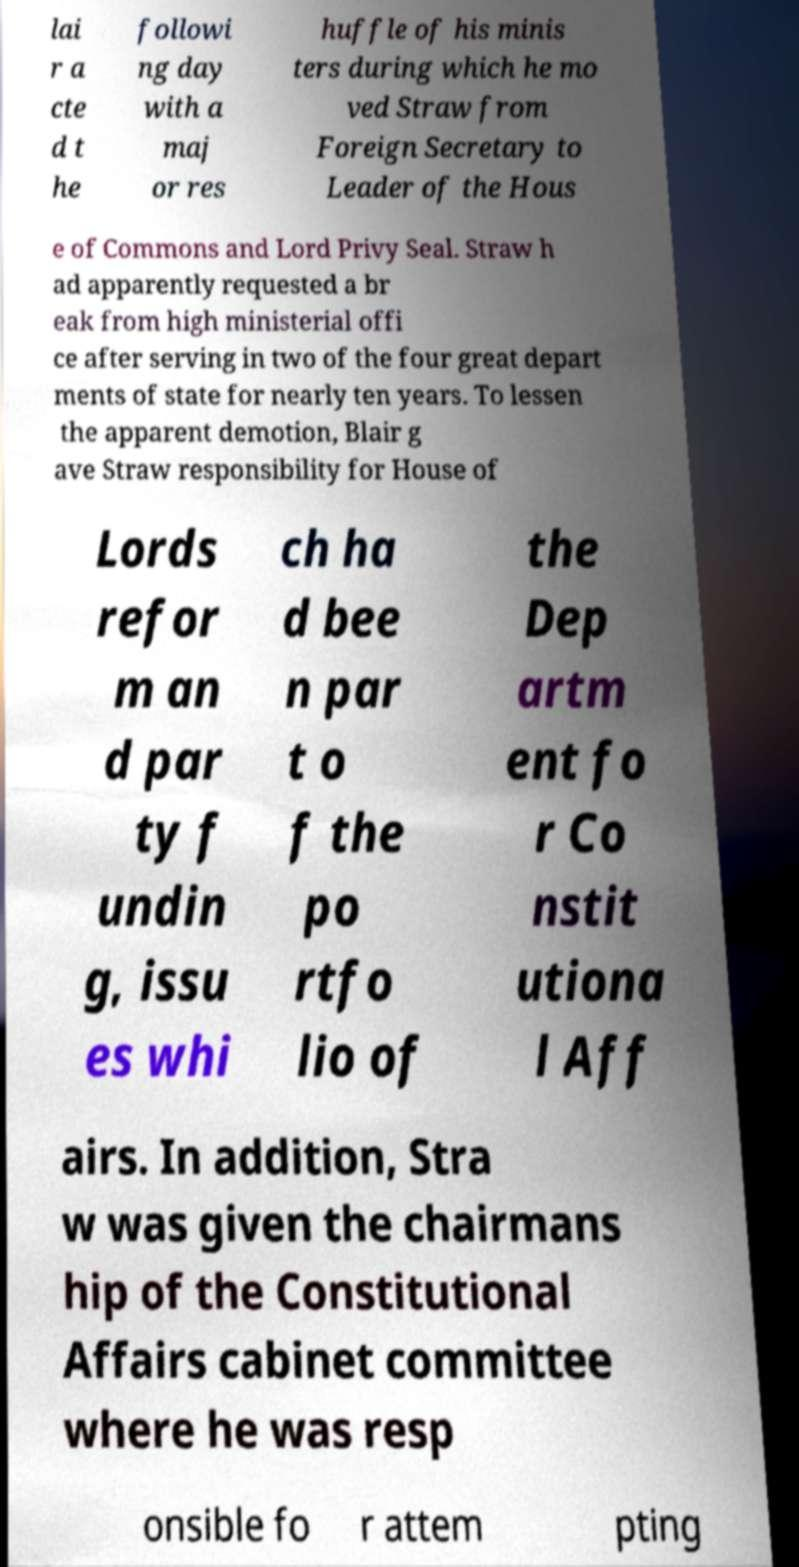Please read and relay the text visible in this image. What does it say? lai r a cte d t he followi ng day with a maj or res huffle of his minis ters during which he mo ved Straw from Foreign Secretary to Leader of the Hous e of Commons and Lord Privy Seal. Straw h ad apparently requested a br eak from high ministerial offi ce after serving in two of the four great depart ments of state for nearly ten years. To lessen the apparent demotion, Blair g ave Straw responsibility for House of Lords refor m an d par ty f undin g, issu es whi ch ha d bee n par t o f the po rtfo lio of the Dep artm ent fo r Co nstit utiona l Aff airs. In addition, Stra w was given the chairmans hip of the Constitutional Affairs cabinet committee where he was resp onsible fo r attem pting 